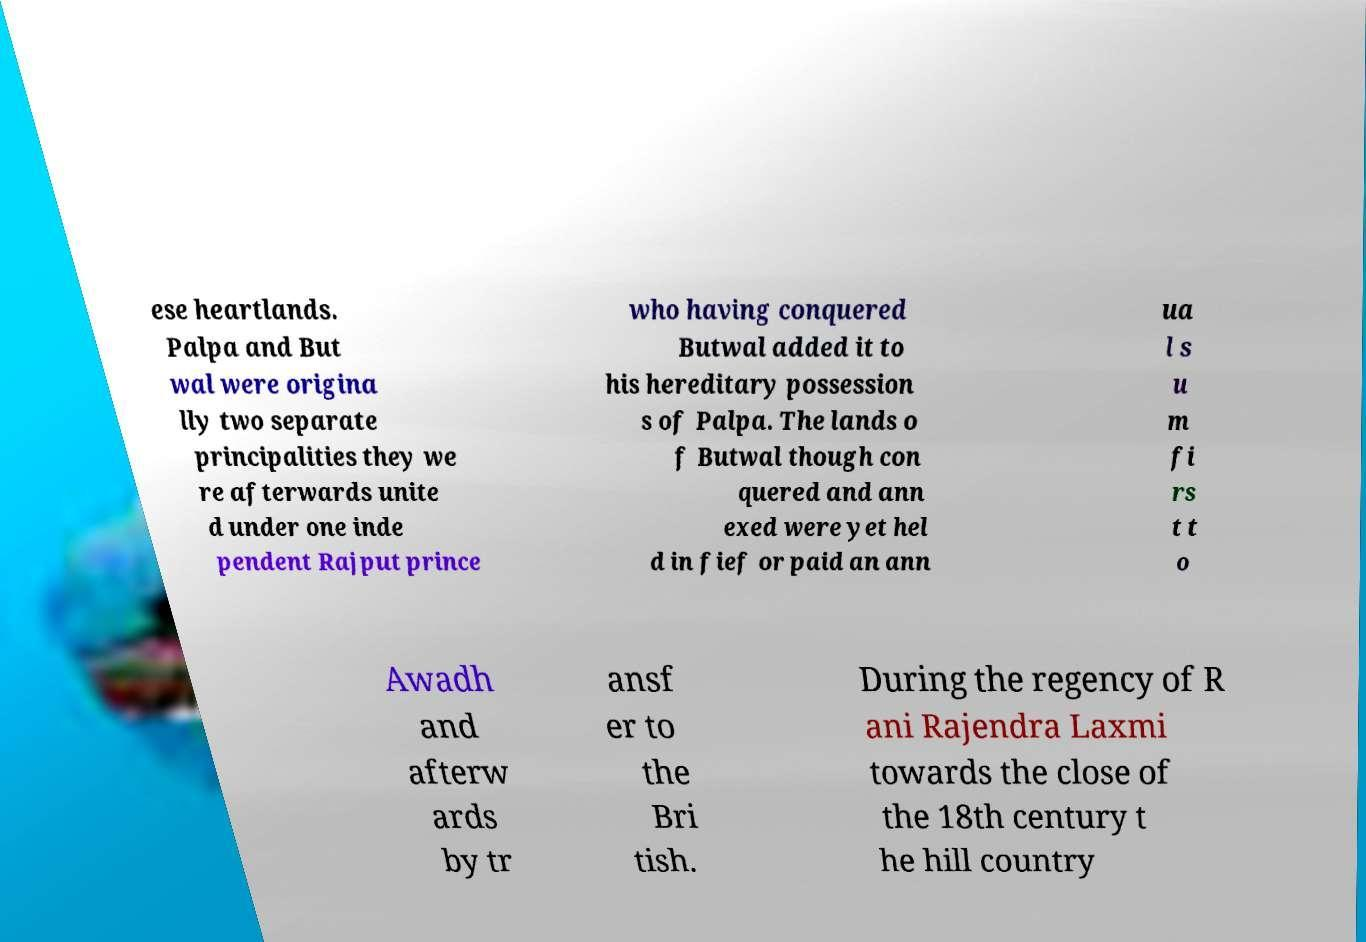Could you assist in decoding the text presented in this image and type it out clearly? ese heartlands. Palpa and But wal were origina lly two separate principalities they we re afterwards unite d under one inde pendent Rajput prince who having conquered Butwal added it to his hereditary possession s of Palpa. The lands o f Butwal though con quered and ann exed were yet hel d in fief or paid an ann ua l s u m fi rs t t o Awadh and afterw ards by tr ansf er to the Bri tish. During the regency of R ani Rajendra Laxmi towards the close of the 18th century t he hill country 